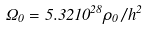<formula> <loc_0><loc_0><loc_500><loc_500>\Omega _ { 0 } = 5 . 3 2 1 0 ^ { 2 8 } \rho _ { 0 } / h ^ { 2 }</formula> 